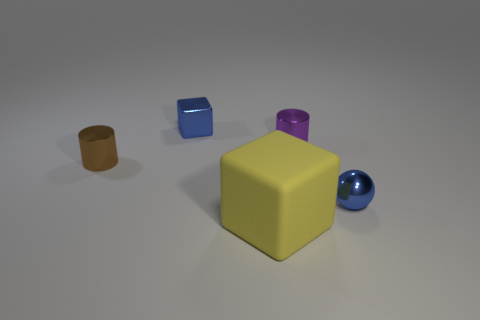Add 3 metal balls. How many objects exist? 8 Subtract all blocks. How many objects are left? 3 Subtract 0 red balls. How many objects are left? 5 Subtract all tiny blue balls. Subtract all shiny balls. How many objects are left? 3 Add 1 large yellow matte blocks. How many large yellow matte blocks are left? 2 Add 1 purple cylinders. How many purple cylinders exist? 2 